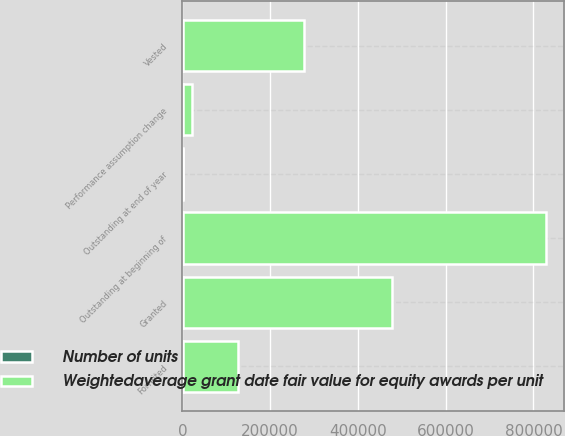Convert chart to OTSL. <chart><loc_0><loc_0><loc_500><loc_500><stacked_bar_chart><ecel><fcel>Outstanding at beginning of<fcel>Granted<fcel>Performance assumption change<fcel>Vested<fcel>Forfeited<fcel>Outstanding at end of year<nl><fcel>Weightedaverage grant date fair value for equity awards per unit<fcel>828228<fcel>478044<fcel>21305<fcel>277261<fcel>126952<fcel>110.97<nl><fcel>Number of units<fcel>102.66<fcel>110.97<fcel>96.71<fcel>109.35<fcel>107.91<fcel>103.11<nl></chart> 